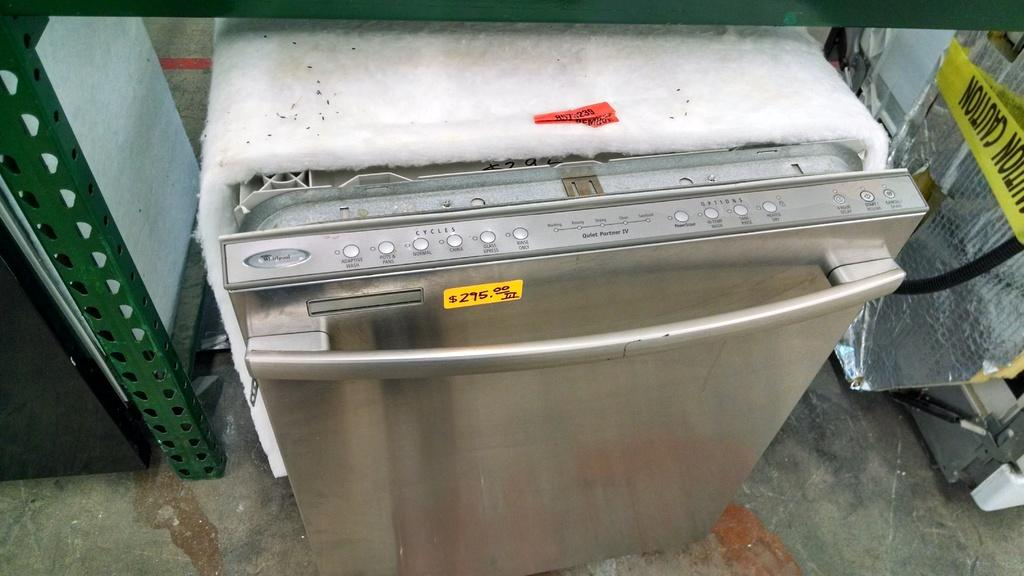<image>
Present a compact description of the photo's key features. A stainless steel dishwasher is being sold for $295.00 